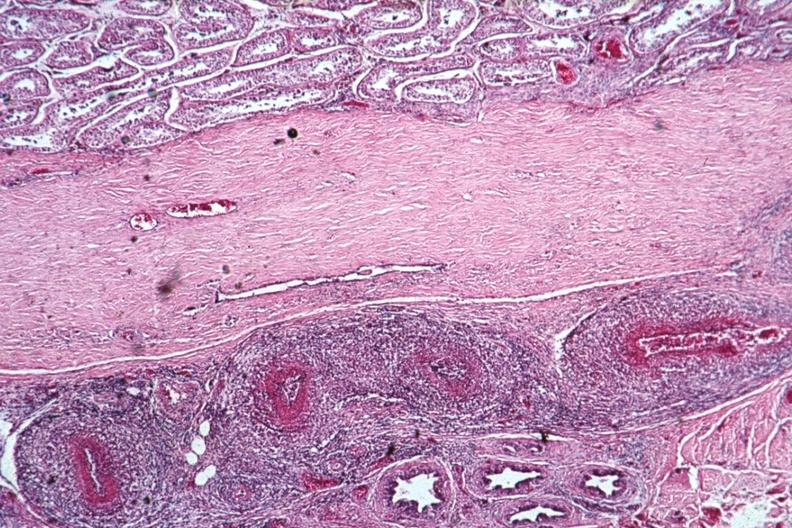what is present?
Answer the question using a single word or phrase. Rheumatoid arthritis with vasculitis 